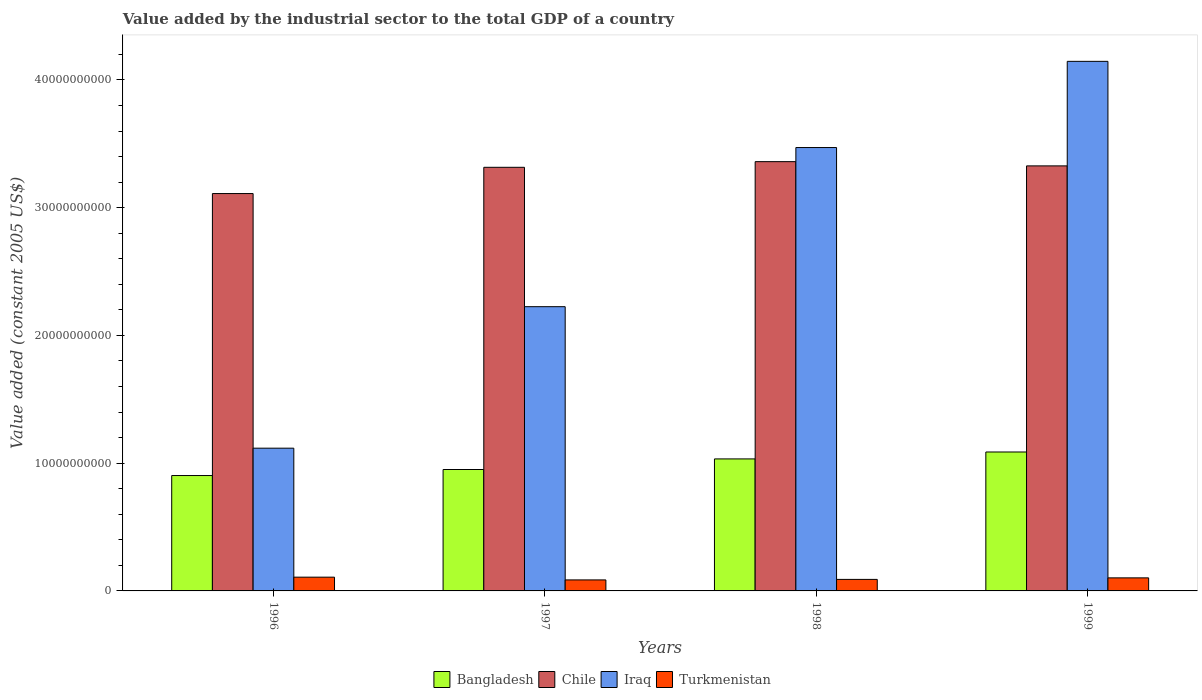Are the number of bars on each tick of the X-axis equal?
Give a very brief answer. Yes. How many bars are there on the 4th tick from the left?
Give a very brief answer. 4. How many bars are there on the 2nd tick from the right?
Keep it short and to the point. 4. In how many cases, is the number of bars for a given year not equal to the number of legend labels?
Your response must be concise. 0. What is the value added by the industrial sector in Turkmenistan in 1998?
Your answer should be very brief. 9.02e+08. Across all years, what is the maximum value added by the industrial sector in Turkmenistan?
Give a very brief answer. 1.08e+09. Across all years, what is the minimum value added by the industrial sector in Chile?
Give a very brief answer. 3.11e+1. What is the total value added by the industrial sector in Turkmenistan in the graph?
Offer a terse response. 3.86e+09. What is the difference between the value added by the industrial sector in Bangladesh in 1996 and that in 1999?
Your answer should be compact. -1.84e+09. What is the difference between the value added by the industrial sector in Chile in 1998 and the value added by the industrial sector in Turkmenistan in 1997?
Your response must be concise. 3.27e+1. What is the average value added by the industrial sector in Chile per year?
Your response must be concise. 3.28e+1. In the year 1997, what is the difference between the value added by the industrial sector in Turkmenistan and value added by the industrial sector in Iraq?
Ensure brevity in your answer.  -2.14e+1. In how many years, is the value added by the industrial sector in Chile greater than 12000000000 US$?
Ensure brevity in your answer.  4. What is the ratio of the value added by the industrial sector in Bangladesh in 1998 to that in 1999?
Ensure brevity in your answer.  0.95. Is the value added by the industrial sector in Iraq in 1996 less than that in 1998?
Make the answer very short. Yes. Is the difference between the value added by the industrial sector in Turkmenistan in 1996 and 1999 greater than the difference between the value added by the industrial sector in Iraq in 1996 and 1999?
Make the answer very short. Yes. What is the difference between the highest and the second highest value added by the industrial sector in Bangladesh?
Make the answer very short. 5.42e+08. What is the difference between the highest and the lowest value added by the industrial sector in Iraq?
Ensure brevity in your answer.  3.03e+1. In how many years, is the value added by the industrial sector in Chile greater than the average value added by the industrial sector in Chile taken over all years?
Keep it short and to the point. 3. Is the sum of the value added by the industrial sector in Bangladesh in 1996 and 1999 greater than the maximum value added by the industrial sector in Chile across all years?
Offer a very short reply. No. Is it the case that in every year, the sum of the value added by the industrial sector in Bangladesh and value added by the industrial sector in Iraq is greater than the sum of value added by the industrial sector in Turkmenistan and value added by the industrial sector in Chile?
Your answer should be very brief. No. Are all the bars in the graph horizontal?
Provide a short and direct response. No. What is the difference between two consecutive major ticks on the Y-axis?
Give a very brief answer. 1.00e+1. Are the values on the major ticks of Y-axis written in scientific E-notation?
Ensure brevity in your answer.  No. Does the graph contain grids?
Keep it short and to the point. No. How are the legend labels stacked?
Offer a terse response. Horizontal. What is the title of the graph?
Ensure brevity in your answer.  Value added by the industrial sector to the total GDP of a country. Does "Lebanon" appear as one of the legend labels in the graph?
Make the answer very short. No. What is the label or title of the Y-axis?
Make the answer very short. Value added (constant 2005 US$). What is the Value added (constant 2005 US$) in Bangladesh in 1996?
Give a very brief answer. 9.03e+09. What is the Value added (constant 2005 US$) in Chile in 1996?
Provide a short and direct response. 3.11e+1. What is the Value added (constant 2005 US$) of Iraq in 1996?
Provide a short and direct response. 1.12e+1. What is the Value added (constant 2005 US$) of Turkmenistan in 1996?
Offer a very short reply. 1.08e+09. What is the Value added (constant 2005 US$) in Bangladesh in 1997?
Your answer should be very brief. 9.50e+09. What is the Value added (constant 2005 US$) of Chile in 1997?
Provide a short and direct response. 3.32e+1. What is the Value added (constant 2005 US$) in Iraq in 1997?
Keep it short and to the point. 2.23e+1. What is the Value added (constant 2005 US$) in Turkmenistan in 1997?
Your answer should be compact. 8.62e+08. What is the Value added (constant 2005 US$) of Bangladesh in 1998?
Your answer should be compact. 1.03e+1. What is the Value added (constant 2005 US$) of Chile in 1998?
Offer a terse response. 3.36e+1. What is the Value added (constant 2005 US$) of Iraq in 1998?
Keep it short and to the point. 3.47e+1. What is the Value added (constant 2005 US$) in Turkmenistan in 1998?
Give a very brief answer. 9.02e+08. What is the Value added (constant 2005 US$) in Bangladesh in 1999?
Provide a succinct answer. 1.09e+1. What is the Value added (constant 2005 US$) of Chile in 1999?
Give a very brief answer. 3.33e+1. What is the Value added (constant 2005 US$) in Iraq in 1999?
Keep it short and to the point. 4.15e+1. What is the Value added (constant 2005 US$) of Turkmenistan in 1999?
Your answer should be compact. 1.02e+09. Across all years, what is the maximum Value added (constant 2005 US$) of Bangladesh?
Keep it short and to the point. 1.09e+1. Across all years, what is the maximum Value added (constant 2005 US$) in Chile?
Offer a very short reply. 3.36e+1. Across all years, what is the maximum Value added (constant 2005 US$) in Iraq?
Provide a succinct answer. 4.15e+1. Across all years, what is the maximum Value added (constant 2005 US$) in Turkmenistan?
Keep it short and to the point. 1.08e+09. Across all years, what is the minimum Value added (constant 2005 US$) in Bangladesh?
Provide a succinct answer. 9.03e+09. Across all years, what is the minimum Value added (constant 2005 US$) of Chile?
Provide a short and direct response. 3.11e+1. Across all years, what is the minimum Value added (constant 2005 US$) of Iraq?
Give a very brief answer. 1.12e+1. Across all years, what is the minimum Value added (constant 2005 US$) of Turkmenistan?
Ensure brevity in your answer.  8.62e+08. What is the total Value added (constant 2005 US$) in Bangladesh in the graph?
Provide a short and direct response. 3.97e+1. What is the total Value added (constant 2005 US$) of Chile in the graph?
Give a very brief answer. 1.31e+11. What is the total Value added (constant 2005 US$) of Iraq in the graph?
Your answer should be compact. 1.10e+11. What is the total Value added (constant 2005 US$) of Turkmenistan in the graph?
Offer a terse response. 3.86e+09. What is the difference between the Value added (constant 2005 US$) of Bangladesh in 1996 and that in 1997?
Your answer should be very brief. -4.72e+08. What is the difference between the Value added (constant 2005 US$) of Chile in 1996 and that in 1997?
Offer a terse response. -2.06e+09. What is the difference between the Value added (constant 2005 US$) of Iraq in 1996 and that in 1997?
Provide a succinct answer. -1.11e+1. What is the difference between the Value added (constant 2005 US$) in Turkmenistan in 1996 and that in 1997?
Your answer should be very brief. 2.15e+08. What is the difference between the Value added (constant 2005 US$) in Bangladesh in 1996 and that in 1998?
Your response must be concise. -1.30e+09. What is the difference between the Value added (constant 2005 US$) in Chile in 1996 and that in 1998?
Keep it short and to the point. -2.50e+09. What is the difference between the Value added (constant 2005 US$) in Iraq in 1996 and that in 1998?
Make the answer very short. -2.35e+1. What is the difference between the Value added (constant 2005 US$) in Turkmenistan in 1996 and that in 1998?
Ensure brevity in your answer.  1.75e+08. What is the difference between the Value added (constant 2005 US$) in Bangladesh in 1996 and that in 1999?
Your answer should be compact. -1.84e+09. What is the difference between the Value added (constant 2005 US$) of Chile in 1996 and that in 1999?
Keep it short and to the point. -2.17e+09. What is the difference between the Value added (constant 2005 US$) in Iraq in 1996 and that in 1999?
Provide a succinct answer. -3.03e+1. What is the difference between the Value added (constant 2005 US$) in Turkmenistan in 1996 and that in 1999?
Offer a terse response. 5.58e+07. What is the difference between the Value added (constant 2005 US$) of Bangladesh in 1997 and that in 1998?
Provide a short and direct response. -8.29e+08. What is the difference between the Value added (constant 2005 US$) in Chile in 1997 and that in 1998?
Provide a short and direct response. -4.42e+08. What is the difference between the Value added (constant 2005 US$) of Iraq in 1997 and that in 1998?
Keep it short and to the point. -1.25e+1. What is the difference between the Value added (constant 2005 US$) of Turkmenistan in 1997 and that in 1998?
Your answer should be compact. -4.05e+07. What is the difference between the Value added (constant 2005 US$) of Bangladesh in 1997 and that in 1999?
Keep it short and to the point. -1.37e+09. What is the difference between the Value added (constant 2005 US$) in Chile in 1997 and that in 1999?
Offer a terse response. -1.11e+08. What is the difference between the Value added (constant 2005 US$) in Iraq in 1997 and that in 1999?
Provide a succinct answer. -1.92e+1. What is the difference between the Value added (constant 2005 US$) in Turkmenistan in 1997 and that in 1999?
Make the answer very short. -1.60e+08. What is the difference between the Value added (constant 2005 US$) in Bangladesh in 1998 and that in 1999?
Make the answer very short. -5.42e+08. What is the difference between the Value added (constant 2005 US$) in Chile in 1998 and that in 1999?
Your answer should be compact. 3.31e+08. What is the difference between the Value added (constant 2005 US$) of Iraq in 1998 and that in 1999?
Give a very brief answer. -6.75e+09. What is the difference between the Value added (constant 2005 US$) of Turkmenistan in 1998 and that in 1999?
Provide a succinct answer. -1.19e+08. What is the difference between the Value added (constant 2005 US$) in Bangladesh in 1996 and the Value added (constant 2005 US$) in Chile in 1997?
Keep it short and to the point. -2.41e+1. What is the difference between the Value added (constant 2005 US$) in Bangladesh in 1996 and the Value added (constant 2005 US$) in Iraq in 1997?
Give a very brief answer. -1.32e+1. What is the difference between the Value added (constant 2005 US$) of Bangladesh in 1996 and the Value added (constant 2005 US$) of Turkmenistan in 1997?
Your answer should be very brief. 8.17e+09. What is the difference between the Value added (constant 2005 US$) in Chile in 1996 and the Value added (constant 2005 US$) in Iraq in 1997?
Your response must be concise. 8.86e+09. What is the difference between the Value added (constant 2005 US$) of Chile in 1996 and the Value added (constant 2005 US$) of Turkmenistan in 1997?
Your answer should be very brief. 3.02e+1. What is the difference between the Value added (constant 2005 US$) of Iraq in 1996 and the Value added (constant 2005 US$) of Turkmenistan in 1997?
Offer a terse response. 1.03e+1. What is the difference between the Value added (constant 2005 US$) in Bangladesh in 1996 and the Value added (constant 2005 US$) in Chile in 1998?
Your response must be concise. -2.46e+1. What is the difference between the Value added (constant 2005 US$) in Bangladesh in 1996 and the Value added (constant 2005 US$) in Iraq in 1998?
Your response must be concise. -2.57e+1. What is the difference between the Value added (constant 2005 US$) of Bangladesh in 1996 and the Value added (constant 2005 US$) of Turkmenistan in 1998?
Provide a succinct answer. 8.13e+09. What is the difference between the Value added (constant 2005 US$) in Chile in 1996 and the Value added (constant 2005 US$) in Iraq in 1998?
Make the answer very short. -3.60e+09. What is the difference between the Value added (constant 2005 US$) in Chile in 1996 and the Value added (constant 2005 US$) in Turkmenistan in 1998?
Provide a short and direct response. 3.02e+1. What is the difference between the Value added (constant 2005 US$) in Iraq in 1996 and the Value added (constant 2005 US$) in Turkmenistan in 1998?
Give a very brief answer. 1.03e+1. What is the difference between the Value added (constant 2005 US$) in Bangladesh in 1996 and the Value added (constant 2005 US$) in Chile in 1999?
Your answer should be very brief. -2.42e+1. What is the difference between the Value added (constant 2005 US$) of Bangladesh in 1996 and the Value added (constant 2005 US$) of Iraq in 1999?
Provide a short and direct response. -3.24e+1. What is the difference between the Value added (constant 2005 US$) in Bangladesh in 1996 and the Value added (constant 2005 US$) in Turkmenistan in 1999?
Provide a short and direct response. 8.01e+09. What is the difference between the Value added (constant 2005 US$) in Chile in 1996 and the Value added (constant 2005 US$) in Iraq in 1999?
Your answer should be very brief. -1.03e+1. What is the difference between the Value added (constant 2005 US$) of Chile in 1996 and the Value added (constant 2005 US$) of Turkmenistan in 1999?
Your answer should be compact. 3.01e+1. What is the difference between the Value added (constant 2005 US$) in Iraq in 1996 and the Value added (constant 2005 US$) in Turkmenistan in 1999?
Ensure brevity in your answer.  1.02e+1. What is the difference between the Value added (constant 2005 US$) of Bangladesh in 1997 and the Value added (constant 2005 US$) of Chile in 1998?
Your answer should be very brief. -2.41e+1. What is the difference between the Value added (constant 2005 US$) of Bangladesh in 1997 and the Value added (constant 2005 US$) of Iraq in 1998?
Offer a very short reply. -2.52e+1. What is the difference between the Value added (constant 2005 US$) of Bangladesh in 1997 and the Value added (constant 2005 US$) of Turkmenistan in 1998?
Give a very brief answer. 8.60e+09. What is the difference between the Value added (constant 2005 US$) in Chile in 1997 and the Value added (constant 2005 US$) in Iraq in 1998?
Your answer should be very brief. -1.55e+09. What is the difference between the Value added (constant 2005 US$) of Chile in 1997 and the Value added (constant 2005 US$) of Turkmenistan in 1998?
Give a very brief answer. 3.23e+1. What is the difference between the Value added (constant 2005 US$) in Iraq in 1997 and the Value added (constant 2005 US$) in Turkmenistan in 1998?
Offer a terse response. 2.13e+1. What is the difference between the Value added (constant 2005 US$) of Bangladesh in 1997 and the Value added (constant 2005 US$) of Chile in 1999?
Provide a succinct answer. -2.38e+1. What is the difference between the Value added (constant 2005 US$) of Bangladesh in 1997 and the Value added (constant 2005 US$) of Iraq in 1999?
Your response must be concise. -3.20e+1. What is the difference between the Value added (constant 2005 US$) in Bangladesh in 1997 and the Value added (constant 2005 US$) in Turkmenistan in 1999?
Your response must be concise. 8.48e+09. What is the difference between the Value added (constant 2005 US$) in Chile in 1997 and the Value added (constant 2005 US$) in Iraq in 1999?
Your answer should be compact. -8.29e+09. What is the difference between the Value added (constant 2005 US$) of Chile in 1997 and the Value added (constant 2005 US$) of Turkmenistan in 1999?
Keep it short and to the point. 3.21e+1. What is the difference between the Value added (constant 2005 US$) of Iraq in 1997 and the Value added (constant 2005 US$) of Turkmenistan in 1999?
Provide a succinct answer. 2.12e+1. What is the difference between the Value added (constant 2005 US$) in Bangladesh in 1998 and the Value added (constant 2005 US$) in Chile in 1999?
Provide a succinct answer. -2.29e+1. What is the difference between the Value added (constant 2005 US$) of Bangladesh in 1998 and the Value added (constant 2005 US$) of Iraq in 1999?
Provide a succinct answer. -3.11e+1. What is the difference between the Value added (constant 2005 US$) in Bangladesh in 1998 and the Value added (constant 2005 US$) in Turkmenistan in 1999?
Your answer should be compact. 9.31e+09. What is the difference between the Value added (constant 2005 US$) of Chile in 1998 and the Value added (constant 2005 US$) of Iraq in 1999?
Your response must be concise. -7.85e+09. What is the difference between the Value added (constant 2005 US$) of Chile in 1998 and the Value added (constant 2005 US$) of Turkmenistan in 1999?
Offer a terse response. 3.26e+1. What is the difference between the Value added (constant 2005 US$) of Iraq in 1998 and the Value added (constant 2005 US$) of Turkmenistan in 1999?
Give a very brief answer. 3.37e+1. What is the average Value added (constant 2005 US$) in Bangladesh per year?
Ensure brevity in your answer.  9.94e+09. What is the average Value added (constant 2005 US$) of Chile per year?
Give a very brief answer. 3.28e+1. What is the average Value added (constant 2005 US$) of Iraq per year?
Your response must be concise. 2.74e+1. What is the average Value added (constant 2005 US$) of Turkmenistan per year?
Provide a succinct answer. 9.66e+08. In the year 1996, what is the difference between the Value added (constant 2005 US$) in Bangladesh and Value added (constant 2005 US$) in Chile?
Your answer should be compact. -2.21e+1. In the year 1996, what is the difference between the Value added (constant 2005 US$) of Bangladesh and Value added (constant 2005 US$) of Iraq?
Your answer should be very brief. -2.14e+09. In the year 1996, what is the difference between the Value added (constant 2005 US$) of Bangladesh and Value added (constant 2005 US$) of Turkmenistan?
Offer a terse response. 7.96e+09. In the year 1996, what is the difference between the Value added (constant 2005 US$) in Chile and Value added (constant 2005 US$) in Iraq?
Your answer should be compact. 1.99e+1. In the year 1996, what is the difference between the Value added (constant 2005 US$) of Chile and Value added (constant 2005 US$) of Turkmenistan?
Provide a succinct answer. 3.00e+1. In the year 1996, what is the difference between the Value added (constant 2005 US$) of Iraq and Value added (constant 2005 US$) of Turkmenistan?
Your answer should be very brief. 1.01e+1. In the year 1997, what is the difference between the Value added (constant 2005 US$) in Bangladesh and Value added (constant 2005 US$) in Chile?
Your answer should be compact. -2.37e+1. In the year 1997, what is the difference between the Value added (constant 2005 US$) in Bangladesh and Value added (constant 2005 US$) in Iraq?
Your answer should be very brief. -1.27e+1. In the year 1997, what is the difference between the Value added (constant 2005 US$) in Bangladesh and Value added (constant 2005 US$) in Turkmenistan?
Make the answer very short. 8.64e+09. In the year 1997, what is the difference between the Value added (constant 2005 US$) of Chile and Value added (constant 2005 US$) of Iraq?
Your answer should be very brief. 1.09e+1. In the year 1997, what is the difference between the Value added (constant 2005 US$) of Chile and Value added (constant 2005 US$) of Turkmenistan?
Offer a very short reply. 3.23e+1. In the year 1997, what is the difference between the Value added (constant 2005 US$) in Iraq and Value added (constant 2005 US$) in Turkmenistan?
Keep it short and to the point. 2.14e+1. In the year 1998, what is the difference between the Value added (constant 2005 US$) of Bangladesh and Value added (constant 2005 US$) of Chile?
Your response must be concise. -2.33e+1. In the year 1998, what is the difference between the Value added (constant 2005 US$) in Bangladesh and Value added (constant 2005 US$) in Iraq?
Your answer should be very brief. -2.44e+1. In the year 1998, what is the difference between the Value added (constant 2005 US$) in Bangladesh and Value added (constant 2005 US$) in Turkmenistan?
Offer a very short reply. 9.43e+09. In the year 1998, what is the difference between the Value added (constant 2005 US$) in Chile and Value added (constant 2005 US$) in Iraq?
Give a very brief answer. -1.10e+09. In the year 1998, what is the difference between the Value added (constant 2005 US$) of Chile and Value added (constant 2005 US$) of Turkmenistan?
Give a very brief answer. 3.27e+1. In the year 1998, what is the difference between the Value added (constant 2005 US$) in Iraq and Value added (constant 2005 US$) in Turkmenistan?
Make the answer very short. 3.38e+1. In the year 1999, what is the difference between the Value added (constant 2005 US$) of Bangladesh and Value added (constant 2005 US$) of Chile?
Make the answer very short. -2.24e+1. In the year 1999, what is the difference between the Value added (constant 2005 US$) of Bangladesh and Value added (constant 2005 US$) of Iraq?
Your answer should be very brief. -3.06e+1. In the year 1999, what is the difference between the Value added (constant 2005 US$) in Bangladesh and Value added (constant 2005 US$) in Turkmenistan?
Ensure brevity in your answer.  9.85e+09. In the year 1999, what is the difference between the Value added (constant 2005 US$) of Chile and Value added (constant 2005 US$) of Iraq?
Provide a short and direct response. -8.18e+09. In the year 1999, what is the difference between the Value added (constant 2005 US$) in Chile and Value added (constant 2005 US$) in Turkmenistan?
Ensure brevity in your answer.  3.23e+1. In the year 1999, what is the difference between the Value added (constant 2005 US$) in Iraq and Value added (constant 2005 US$) in Turkmenistan?
Provide a succinct answer. 4.04e+1. What is the ratio of the Value added (constant 2005 US$) in Bangladesh in 1996 to that in 1997?
Keep it short and to the point. 0.95. What is the ratio of the Value added (constant 2005 US$) in Chile in 1996 to that in 1997?
Your answer should be very brief. 0.94. What is the ratio of the Value added (constant 2005 US$) of Iraq in 1996 to that in 1997?
Your answer should be very brief. 0.5. What is the ratio of the Value added (constant 2005 US$) in Turkmenistan in 1996 to that in 1997?
Make the answer very short. 1.25. What is the ratio of the Value added (constant 2005 US$) in Bangladesh in 1996 to that in 1998?
Give a very brief answer. 0.87. What is the ratio of the Value added (constant 2005 US$) of Chile in 1996 to that in 1998?
Give a very brief answer. 0.93. What is the ratio of the Value added (constant 2005 US$) in Iraq in 1996 to that in 1998?
Your response must be concise. 0.32. What is the ratio of the Value added (constant 2005 US$) in Turkmenistan in 1996 to that in 1998?
Provide a short and direct response. 1.19. What is the ratio of the Value added (constant 2005 US$) of Bangladesh in 1996 to that in 1999?
Your answer should be very brief. 0.83. What is the ratio of the Value added (constant 2005 US$) in Chile in 1996 to that in 1999?
Provide a short and direct response. 0.93. What is the ratio of the Value added (constant 2005 US$) of Iraq in 1996 to that in 1999?
Make the answer very short. 0.27. What is the ratio of the Value added (constant 2005 US$) of Turkmenistan in 1996 to that in 1999?
Offer a terse response. 1.05. What is the ratio of the Value added (constant 2005 US$) in Bangladesh in 1997 to that in 1998?
Offer a very short reply. 0.92. What is the ratio of the Value added (constant 2005 US$) of Chile in 1997 to that in 1998?
Offer a very short reply. 0.99. What is the ratio of the Value added (constant 2005 US$) in Iraq in 1997 to that in 1998?
Make the answer very short. 0.64. What is the ratio of the Value added (constant 2005 US$) of Turkmenistan in 1997 to that in 1998?
Your response must be concise. 0.96. What is the ratio of the Value added (constant 2005 US$) in Bangladesh in 1997 to that in 1999?
Offer a terse response. 0.87. What is the ratio of the Value added (constant 2005 US$) in Chile in 1997 to that in 1999?
Offer a terse response. 1. What is the ratio of the Value added (constant 2005 US$) in Iraq in 1997 to that in 1999?
Give a very brief answer. 0.54. What is the ratio of the Value added (constant 2005 US$) of Turkmenistan in 1997 to that in 1999?
Ensure brevity in your answer.  0.84. What is the ratio of the Value added (constant 2005 US$) of Bangladesh in 1998 to that in 1999?
Make the answer very short. 0.95. What is the ratio of the Value added (constant 2005 US$) of Chile in 1998 to that in 1999?
Provide a succinct answer. 1.01. What is the ratio of the Value added (constant 2005 US$) of Iraq in 1998 to that in 1999?
Give a very brief answer. 0.84. What is the ratio of the Value added (constant 2005 US$) in Turkmenistan in 1998 to that in 1999?
Ensure brevity in your answer.  0.88. What is the difference between the highest and the second highest Value added (constant 2005 US$) in Bangladesh?
Make the answer very short. 5.42e+08. What is the difference between the highest and the second highest Value added (constant 2005 US$) of Chile?
Your answer should be very brief. 3.31e+08. What is the difference between the highest and the second highest Value added (constant 2005 US$) in Iraq?
Offer a terse response. 6.75e+09. What is the difference between the highest and the second highest Value added (constant 2005 US$) in Turkmenistan?
Make the answer very short. 5.58e+07. What is the difference between the highest and the lowest Value added (constant 2005 US$) of Bangladesh?
Your answer should be compact. 1.84e+09. What is the difference between the highest and the lowest Value added (constant 2005 US$) of Chile?
Ensure brevity in your answer.  2.50e+09. What is the difference between the highest and the lowest Value added (constant 2005 US$) in Iraq?
Make the answer very short. 3.03e+1. What is the difference between the highest and the lowest Value added (constant 2005 US$) in Turkmenistan?
Offer a very short reply. 2.15e+08. 